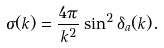<formula> <loc_0><loc_0><loc_500><loc_500>\sigma ( k ) = \frac { 4 \pi } { k ^ { 2 } } \sin ^ { 2 } \delta _ { a } ( k ) .</formula> 